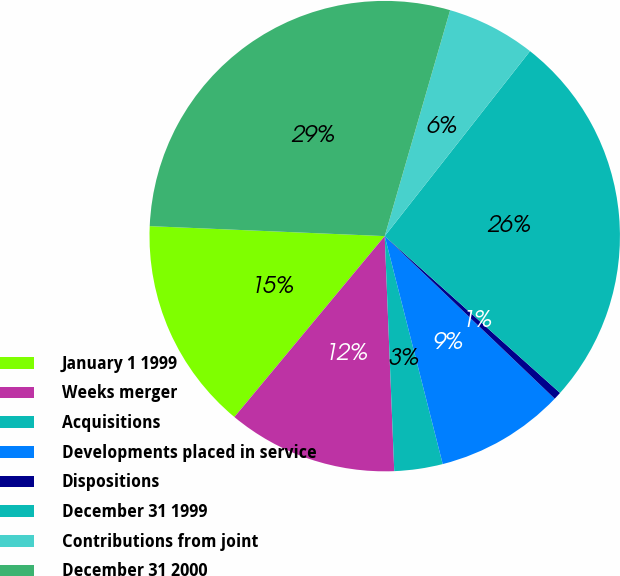<chart> <loc_0><loc_0><loc_500><loc_500><pie_chart><fcel>January 1 1999<fcel>Weeks merger<fcel>Acquisitions<fcel>Developments placed in service<fcel>Dispositions<fcel>December 31 1999<fcel>Contributions from joint<fcel>December 31 2000<nl><fcel>14.64%<fcel>11.68%<fcel>3.32%<fcel>8.89%<fcel>0.53%<fcel>26.02%<fcel>6.11%<fcel>28.81%<nl></chart> 